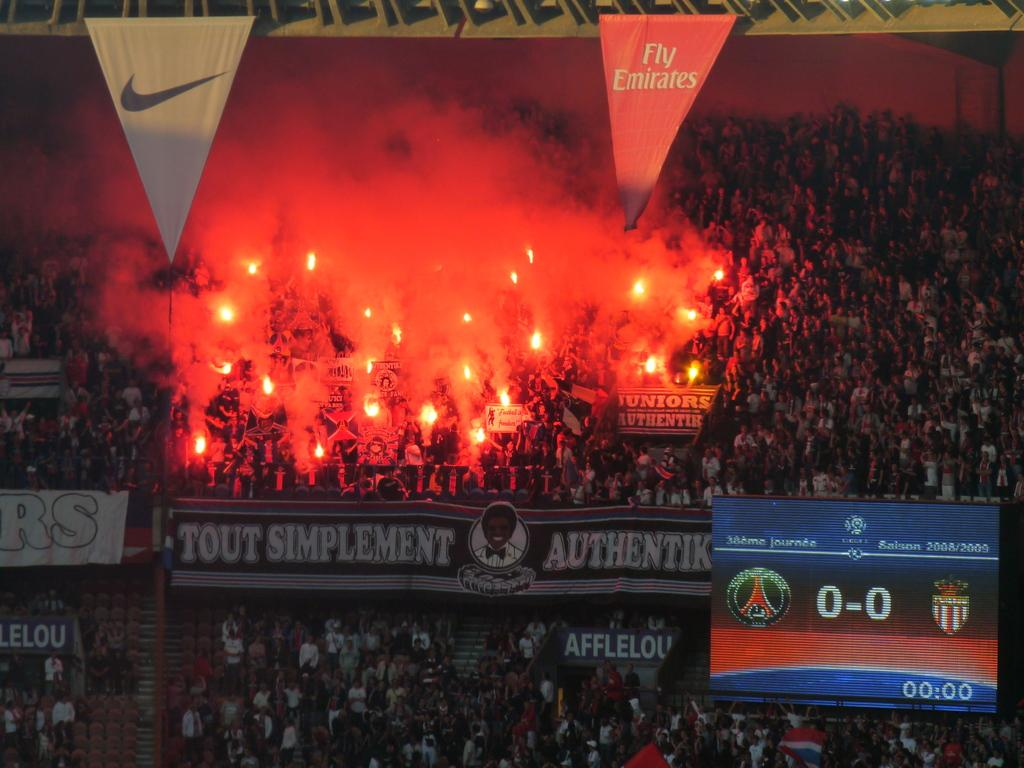Provide a one-sentence caption for the provided image. A stadium filled with people with a Nike and Fly Emirates banner handing above the crowd. 